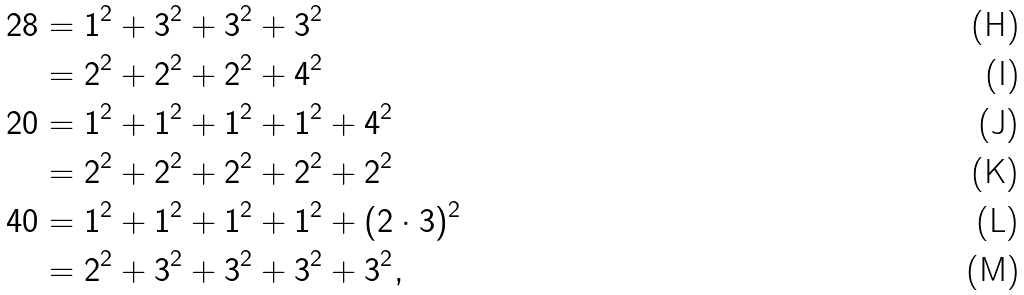Convert formula to latex. <formula><loc_0><loc_0><loc_500><loc_500>2 8 & = 1 ^ { 2 } + 3 ^ { 2 } + 3 ^ { 2 } + 3 ^ { 2 } \\ & = 2 ^ { 2 } + 2 ^ { 2 } + 2 ^ { 2 } + 4 ^ { 2 } \\ 2 0 & = 1 ^ { 2 } + 1 ^ { 2 } + 1 ^ { 2 } + 1 ^ { 2 } + 4 ^ { 2 } \\ & = 2 ^ { 2 } + 2 ^ { 2 } + 2 ^ { 2 } + 2 ^ { 2 } + 2 ^ { 2 } \\ 4 0 & = 1 ^ { 2 } + 1 ^ { 2 } + 1 ^ { 2 } + 1 ^ { 2 } + ( 2 \cdot 3 ) ^ { 2 } \\ & = 2 ^ { 2 } + 3 ^ { 2 } + 3 ^ { 2 } + 3 ^ { 2 } + 3 ^ { 2 } ,</formula> 